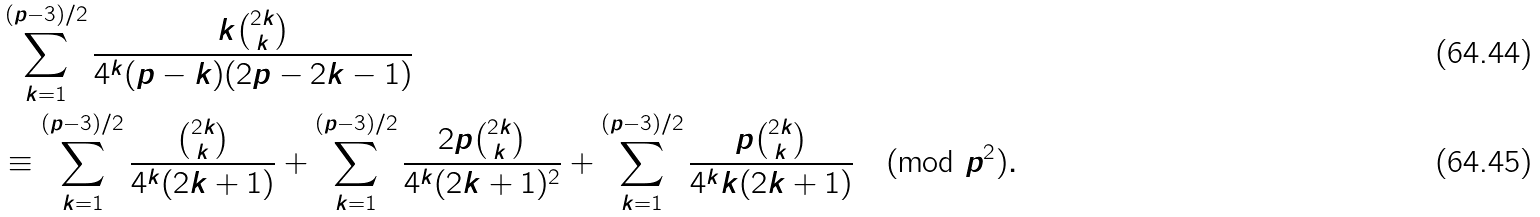<formula> <loc_0><loc_0><loc_500><loc_500>& \sum _ { k = 1 } ^ { ( p - 3 ) / 2 } \frac { k \binom { 2 k } k } { 4 ^ { k } ( p - k ) ( 2 p - 2 k - 1 ) } \\ & \equiv \sum _ { k = 1 } ^ { ( p - 3 ) / 2 } \frac { \binom { 2 k } k } { 4 ^ { k } ( 2 k + 1 ) } + \sum _ { k = 1 } ^ { ( p - 3 ) / 2 } \frac { 2 p \binom { 2 k } k } { 4 ^ { k } ( 2 k + 1 ) ^ { 2 } } + \sum _ { k = 1 } ^ { ( p - 3 ) / 2 } \frac { p \binom { 2 k } k } { 4 ^ { k } k ( 2 k + 1 ) } \pmod { p ^ { 2 } } .</formula> 